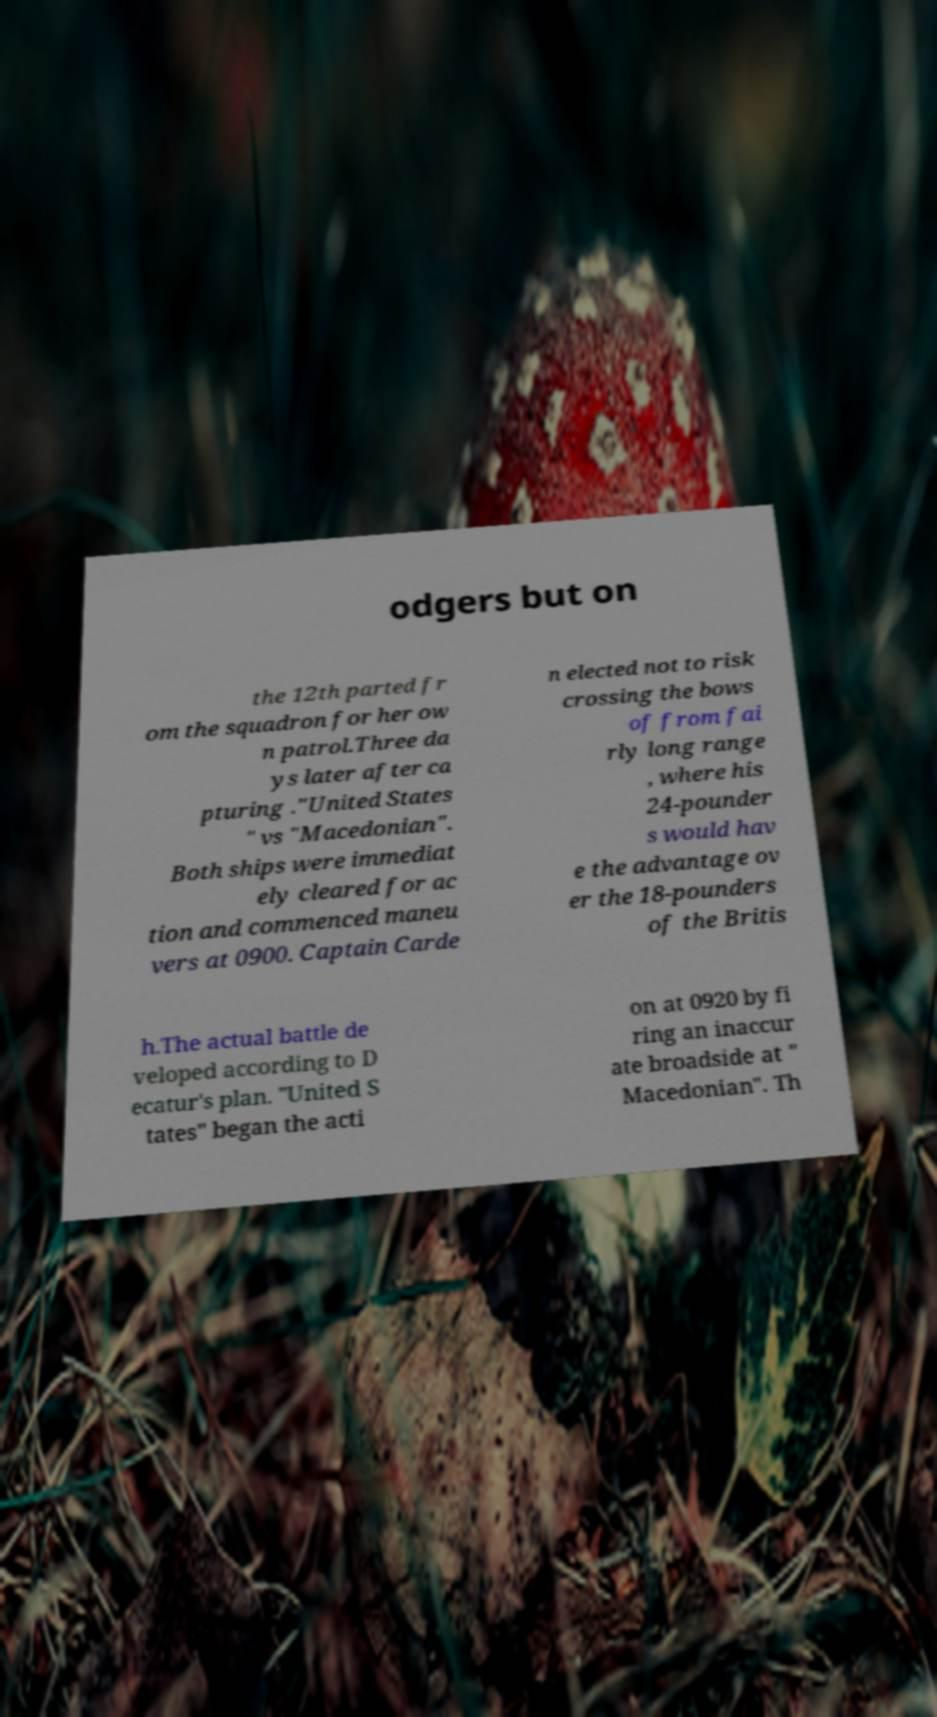Can you read and provide the text displayed in the image?This photo seems to have some interesting text. Can you extract and type it out for me? odgers but on the 12th parted fr om the squadron for her ow n patrol.Three da ys later after ca pturing ."United States " vs "Macedonian". Both ships were immediat ely cleared for ac tion and commenced maneu vers at 0900. Captain Carde n elected not to risk crossing the bows of from fai rly long range , where his 24-pounder s would hav e the advantage ov er the 18-pounders of the Britis h.The actual battle de veloped according to D ecatur's plan. "United S tates" began the acti on at 0920 by fi ring an inaccur ate broadside at " Macedonian". Th 